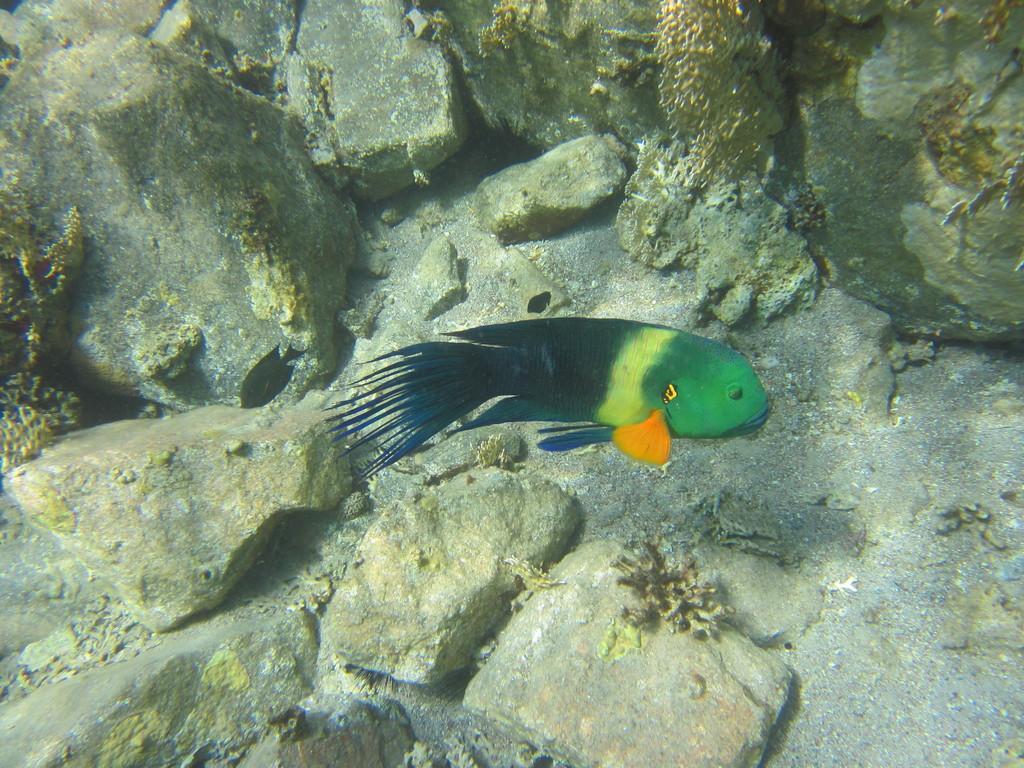Describe this image in one or two sentences. In this image there is a fish in the water and there are some rocks and algae. 